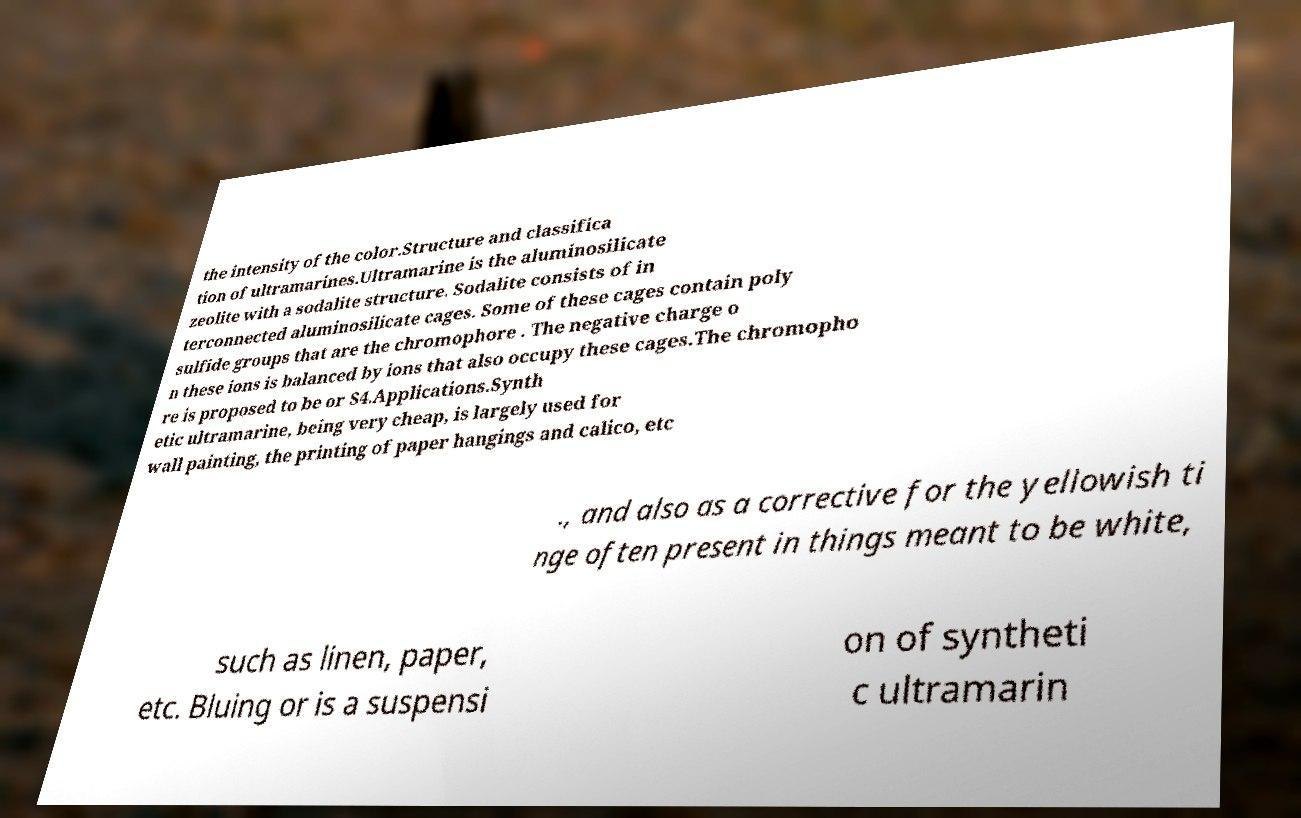I need the written content from this picture converted into text. Can you do that? the intensity of the color.Structure and classifica tion of ultramarines.Ultramarine is the aluminosilicate zeolite with a sodalite structure. Sodalite consists of in terconnected aluminosilicate cages. Some of these cages contain poly sulfide groups that are the chromophore . The negative charge o n these ions is balanced by ions that also occupy these cages.The chromopho re is proposed to be or S4.Applications.Synth etic ultramarine, being very cheap, is largely used for wall painting, the printing of paper hangings and calico, etc ., and also as a corrective for the yellowish ti nge often present in things meant to be white, such as linen, paper, etc. Bluing or is a suspensi on of syntheti c ultramarin 